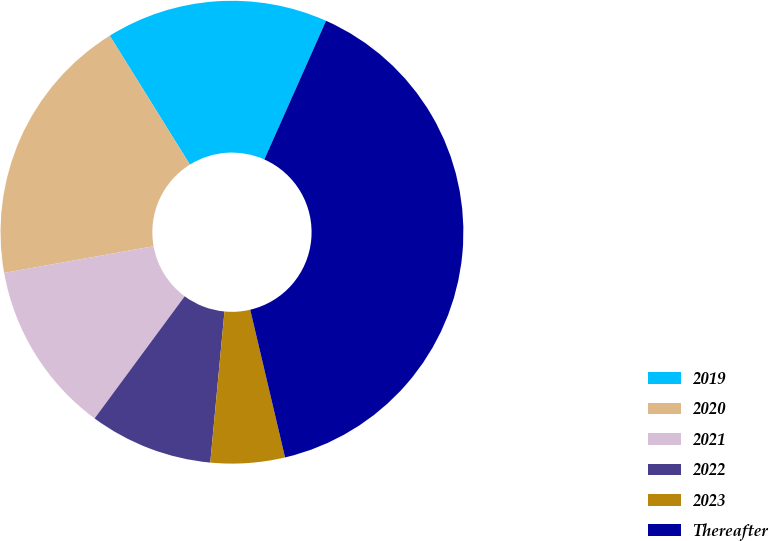Convert chart. <chart><loc_0><loc_0><loc_500><loc_500><pie_chart><fcel>2019<fcel>2020<fcel>2021<fcel>2022<fcel>2023<fcel>Thereafter<nl><fcel>15.52%<fcel>18.96%<fcel>12.07%<fcel>8.62%<fcel>5.18%<fcel>39.65%<nl></chart> 